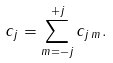Convert formula to latex. <formula><loc_0><loc_0><loc_500><loc_500>c _ { j } = \sum _ { m = - j } ^ { + j } c _ { j \, m } .</formula> 